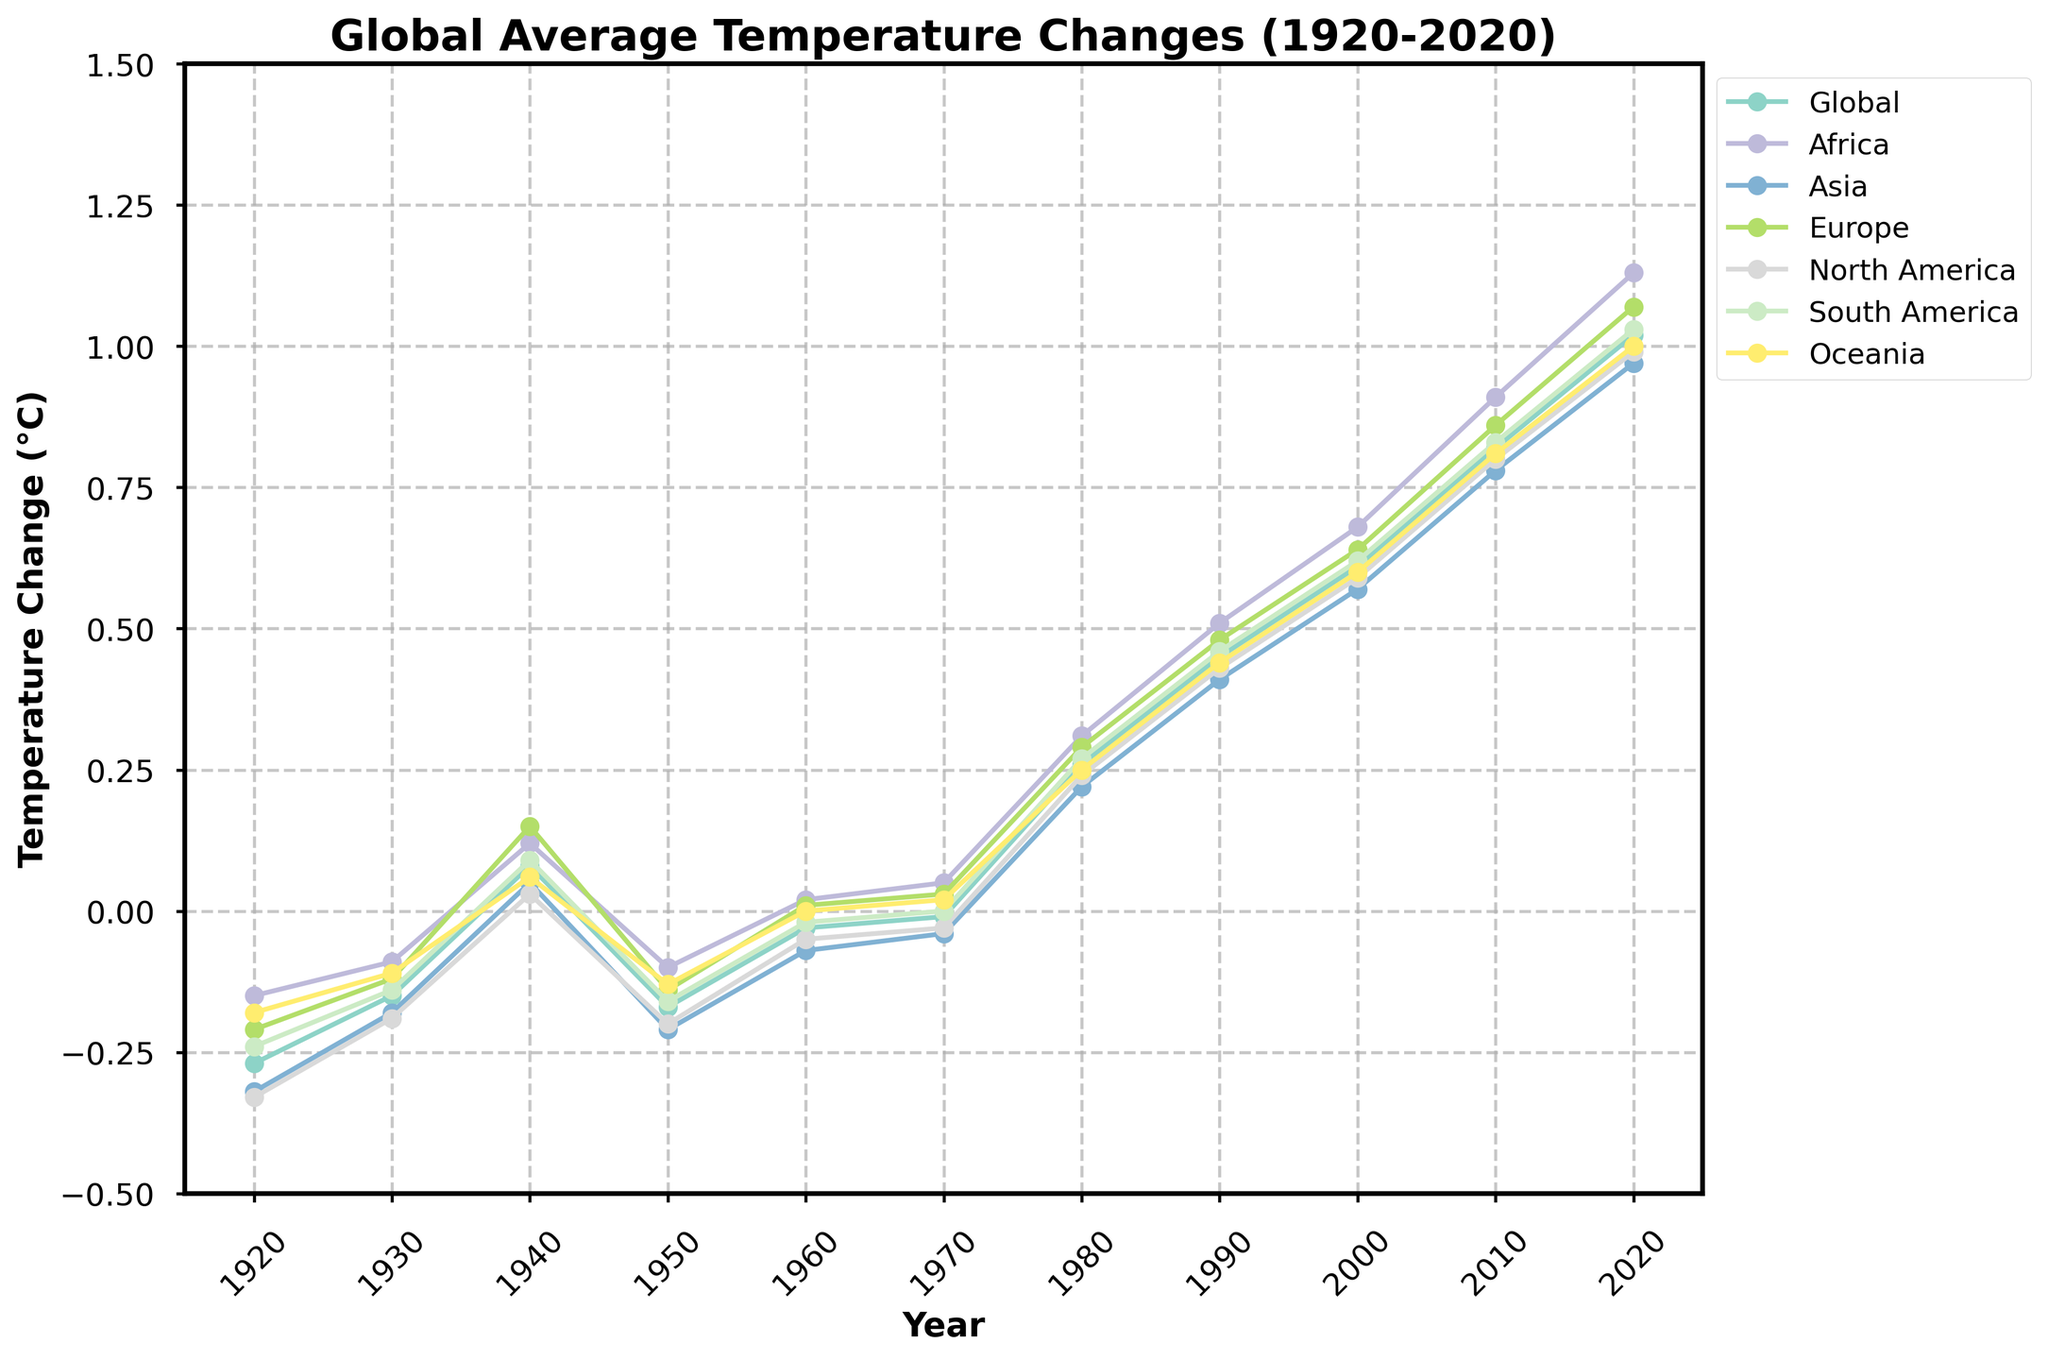What's the overall trend of global average temperatures from 1920 to 2020? To understand this, observe the overall direction of the line representing the global temperature from 1920 to 2020. The line consistently moves upwards indicating an increase in global average temperature over the century.
Answer: Upward trend Which continent experienced the largest temperature increase from 1920 to 2020? Compare the temperature increase for each continent between 1920 and 2020 by subtracting the 1920 value from the 2020 value for each. The continent with the highest difference experienced the largest increase.
Answer: Africa Between 1980 and 2020, during which decade did the global temperature see the most significant increase? Look at the changes in the global temperature line for each decade between 1980 and 2020. Identify the decade with the steepest upward slope.
Answer: 2010s How does the temperature change in Europe in 1970 compare to the global average temperature change in the same year? Find and compare the points on the line representing Europe and the global average for the year 1970. Observe their positions relative to the vertical temperature axis.
Answer: Europe is higher What was the temperature change difference between Asia and North America in 1940? Subtract the 1940 temperature change value for North America from that of Asia to find the difference.
Answer: 0.02°C Which continent had the least temperature change variation between 1930 and 2020? To determine this, examine the temperature changes for each continent from 1930 to 2020 and look for the continent where the line is the flattest or where the change is least drastic.
Answer: Oceania At what point in time did South America's temperature change cross from negative to positive? Identify the years in South America's line where it crosses the zero point on the temperature axis, noting the first such crossing time.
Answer: 1980s Analyze the decadal temperature trend in North America from 1950 to 1970. How did it change? Observe the points for North America at 1950, 1960, and 1970. Note whether the points trend upwards, downwards, or remain consistent over the decades.
Answer: Decreasing trend 